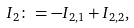Convert formula to latex. <formula><loc_0><loc_0><loc_500><loc_500>I _ { 2 } \colon = - I _ { 2 , 1 } + I _ { 2 , 2 } ,</formula> 